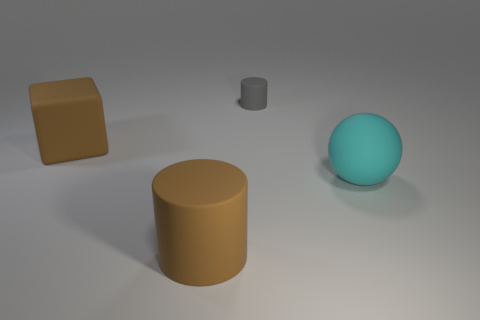Add 1 big green things. How many objects exist? 5 Subtract all balls. How many objects are left? 3 Subtract all large cylinders. Subtract all cyan matte balls. How many objects are left? 2 Add 2 rubber objects. How many rubber objects are left? 6 Add 3 tiny green metal blocks. How many tiny green metal blocks exist? 3 Subtract 0 blue spheres. How many objects are left? 4 